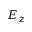<formula> <loc_0><loc_0><loc_500><loc_500>E _ { z }</formula> 